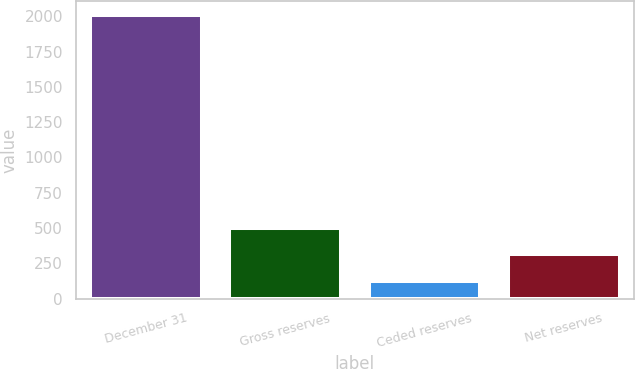<chart> <loc_0><loc_0><loc_500><loc_500><bar_chart><fcel>December 31<fcel>Gross reserves<fcel>Ceded reserves<fcel>Net reserves<nl><fcel>2007<fcel>501.4<fcel>125<fcel>313.2<nl></chart> 